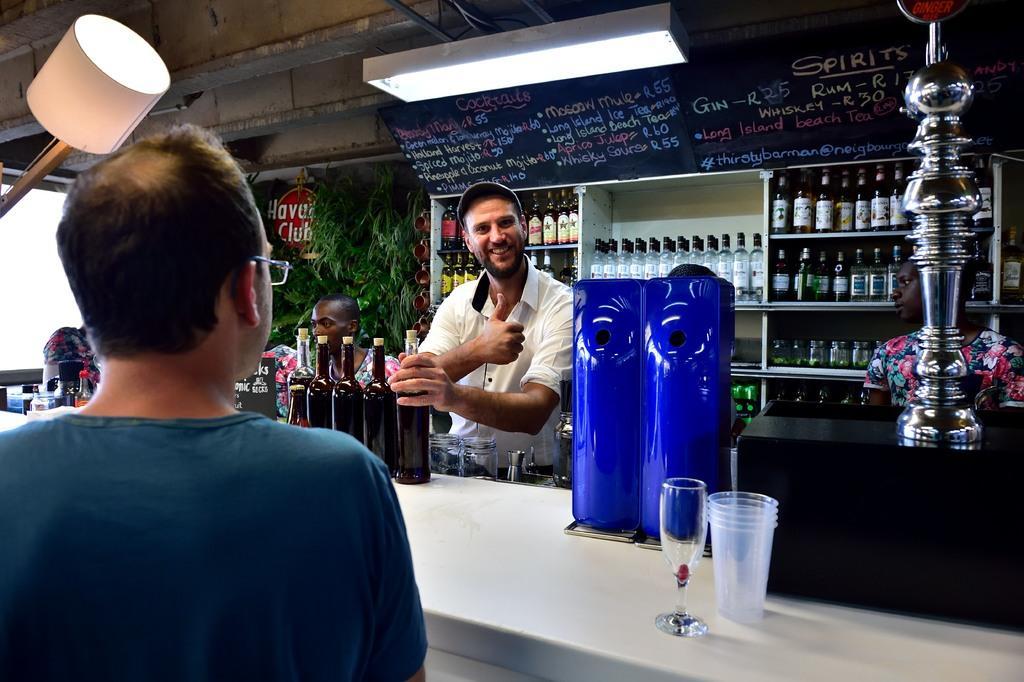How would you summarize this image in a sentence or two? In this picture we can see a person standing and holding a wine bottle in his hand, and at back there are many bottles in the rack, and here is the person sitting, and here is the table in front with glass and wine glass ,and here is the person standing on the floor. 